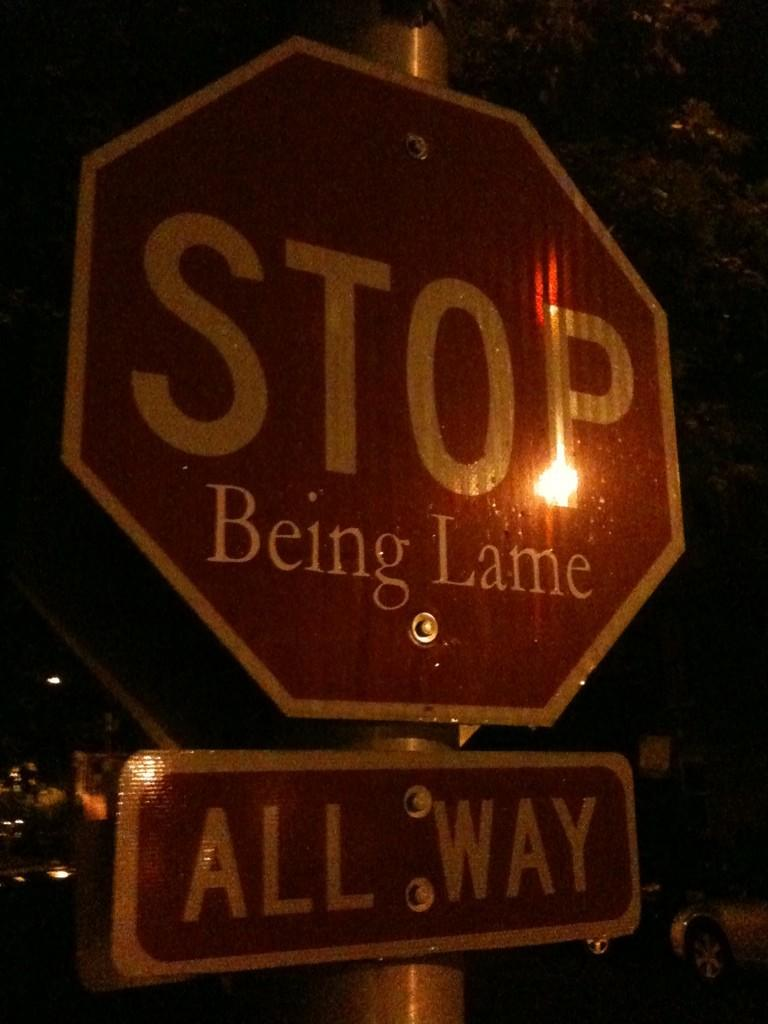<image>
Write a terse but informative summary of the picture. A street sign is altered to say Stop Being Lame. 